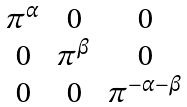Convert formula to latex. <formula><loc_0><loc_0><loc_500><loc_500>\begin{matrix} \pi ^ { \alpha } & 0 & 0 \\ 0 & \pi ^ { \beta } & 0 \\ 0 & 0 & \pi ^ { - \alpha - \beta } \end{matrix}</formula> 